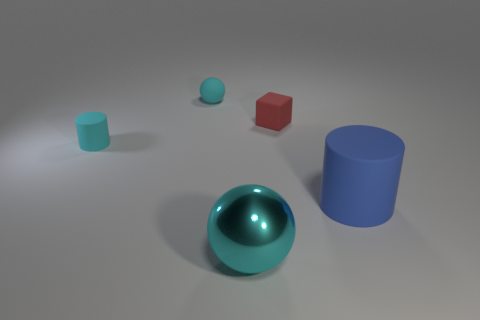Add 1 small spheres. How many objects exist? 6 Subtract all balls. How many objects are left? 3 Subtract 0 blue blocks. How many objects are left? 5 Subtract all small rubber cylinders. Subtract all matte cylinders. How many objects are left? 2 Add 2 small red rubber objects. How many small red rubber objects are left? 3 Add 4 cylinders. How many cylinders exist? 6 